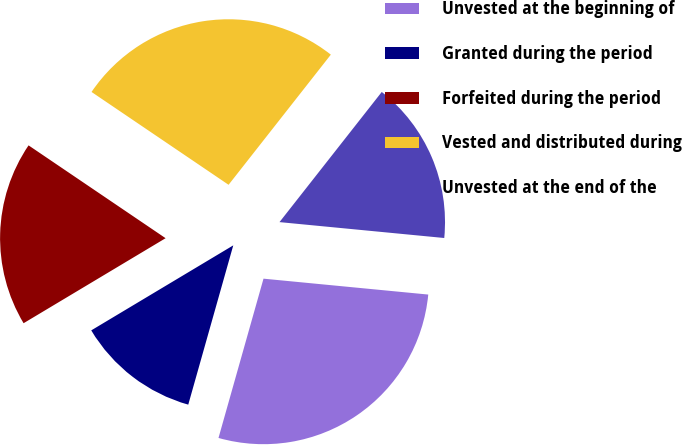Convert chart. <chart><loc_0><loc_0><loc_500><loc_500><pie_chart><fcel>Unvested at the beginning of<fcel>Granted during the period<fcel>Forfeited during the period<fcel>Vested and distributed during<fcel>Unvested at the end of the<nl><fcel>27.85%<fcel>12.03%<fcel>18.06%<fcel>26.12%<fcel>15.93%<nl></chart> 